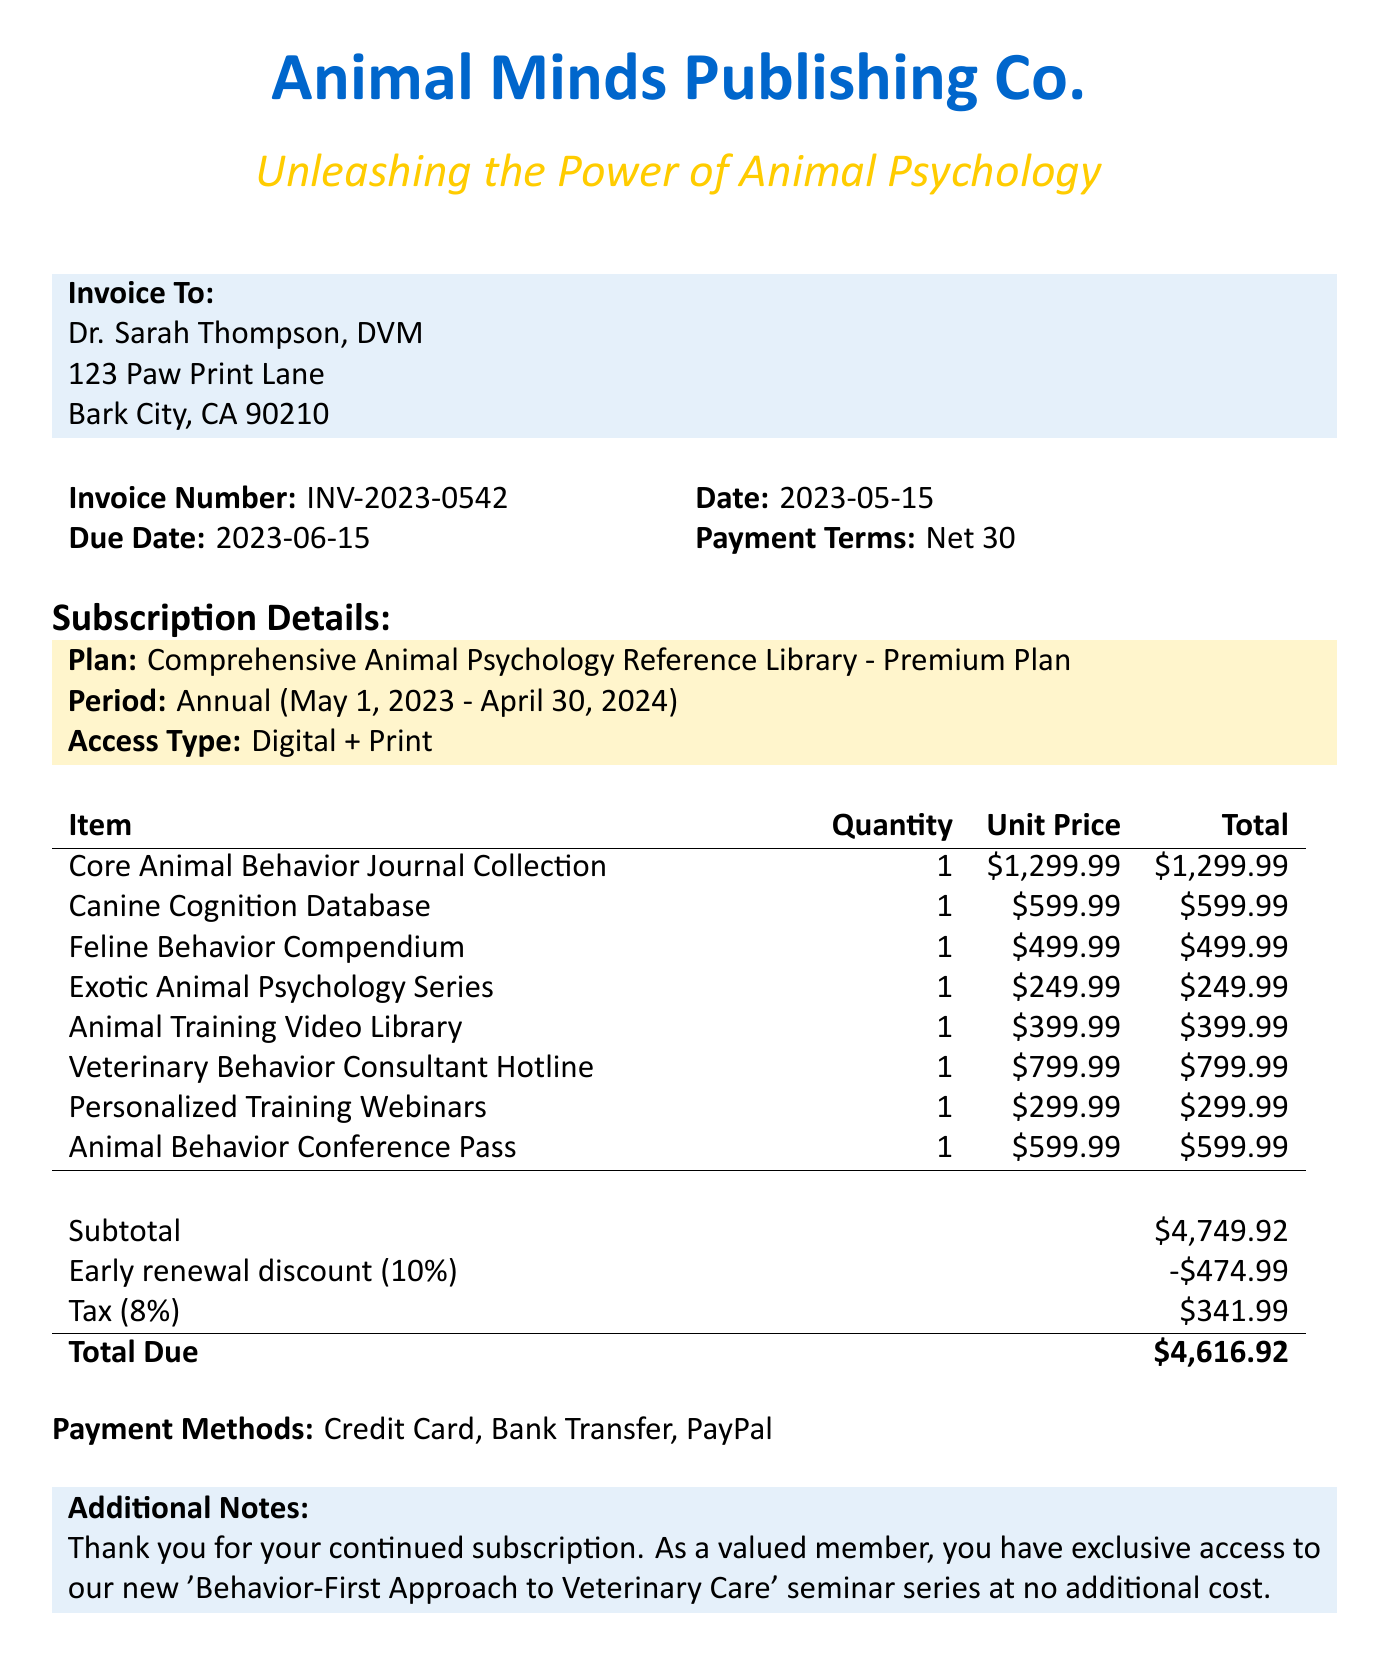What is the invoice number? The invoice number is explicitly stated in the document as a specific identifier for the billing statement.
Answer: INV-2023-0542 What is the total amount due? The total amount due is the final amount listed at the bottom of the invoice, reflecting the overall charges after discounts and taxes.
Answer: $4,616.92 What is the subscription period? The subscription period details the start and end date of the service, which is provided in the subscription details section.
Answer: Annual (May 1, 2023 - April 30, 2024) How much is the early renewal discount? The early renewal discount is explicitly provided in the summary section of the invoice to identify the reduction in the total amount owed.
Answer: $474.99 What access type is provided with the premium plan? The access type reflects the kind of materials available to the client as stated in the subscription details.
Answer: Digital + Print What is the due date for the invoice? The due date indicates when the payment must be made, which is listed in the header of the invoice.
Answer: 2023-06-15 What types of payment methods are accepted? The payment methods are listed in the invoice to specify how payment can be made by the client.
Answer: Credit Card, Bank Transfer, PayPal What item has the highest unit price? The item with the highest unit price is specified in the line items section and indicates which resource costs the most.
Answer: Core Animal Behavior Journal Collection What additional service is available at no extra cost? The additional notes section mentions a specific available service for subscribers that does not incur extra charges.
Answer: 'Behavior-First Approach to Veterinary Care' seminar series 